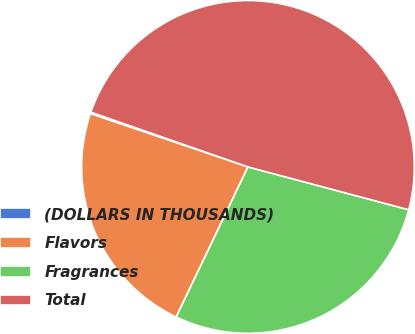Convert chart to OTSL. <chart><loc_0><loc_0><loc_500><loc_500><pie_chart><fcel>(DOLLARS IN THOUSANDS)<fcel>Flavors<fcel>Fragrances<fcel>Total<nl><fcel>0.15%<fcel>23.09%<fcel>27.95%<fcel>48.81%<nl></chart> 